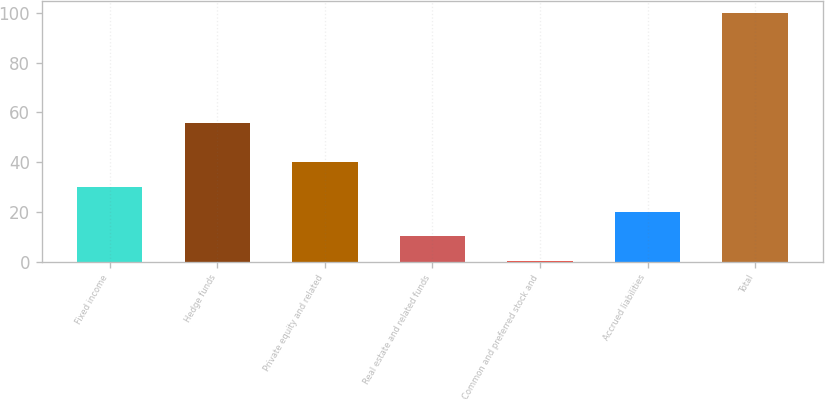Convert chart. <chart><loc_0><loc_0><loc_500><loc_500><bar_chart><fcel>Fixed income<fcel>Hedge funds<fcel>Private equity and related<fcel>Real estate and related funds<fcel>Common and preferred stock and<fcel>Accrued liabilities<fcel>Total<nl><fcel>30.07<fcel>55.9<fcel>40.06<fcel>10.09<fcel>0.1<fcel>20.08<fcel>100<nl></chart> 